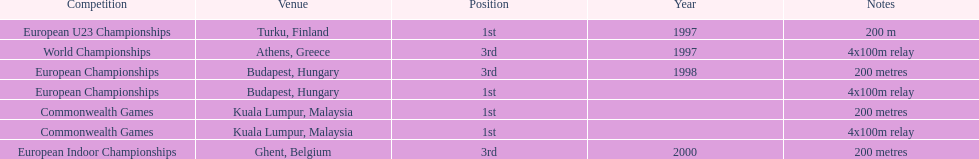How many competitions were in budapest, hungary and came in 1st position? 1. 